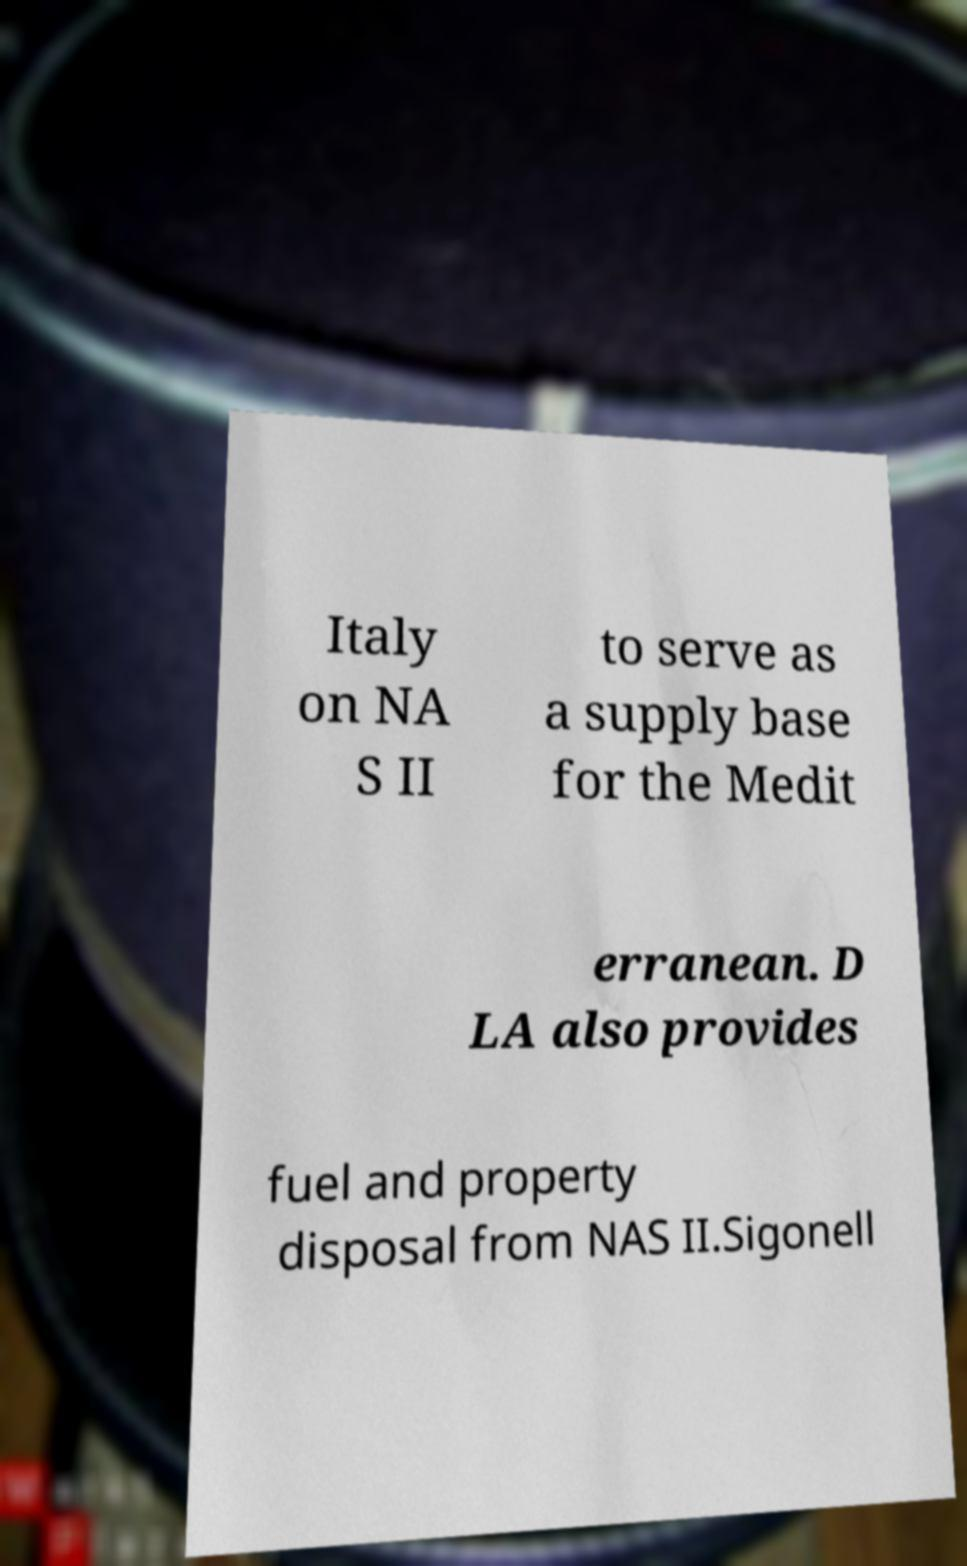Please identify and transcribe the text found in this image. Italy on NA S II to serve as a supply base for the Medit erranean. D LA also provides fuel and property disposal from NAS II.Sigonell 